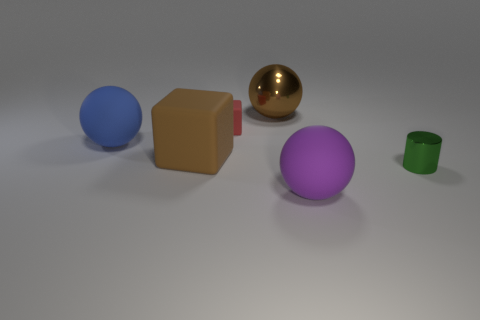Subtract all large matte balls. How many balls are left? 1 Add 1 small brown blocks. How many objects exist? 7 Subtract all cylinders. How many objects are left? 5 Add 1 metallic spheres. How many metallic spheres exist? 2 Subtract 0 purple cylinders. How many objects are left? 6 Subtract all small metal objects. Subtract all big rubber blocks. How many objects are left? 4 Add 1 small green metallic things. How many small green metallic things are left? 2 